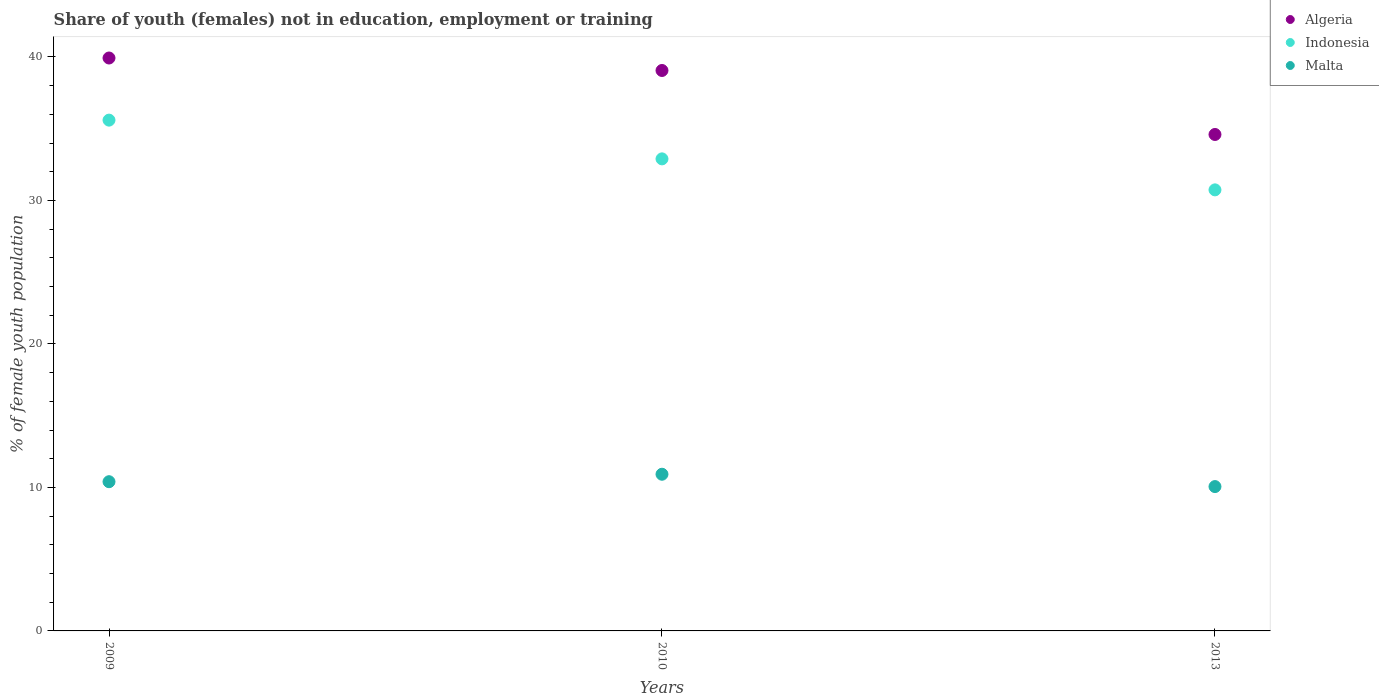How many different coloured dotlines are there?
Keep it short and to the point. 3. What is the percentage of unemployed female population in in Algeria in 2009?
Your response must be concise. 39.93. Across all years, what is the maximum percentage of unemployed female population in in Indonesia?
Offer a very short reply. 35.6. Across all years, what is the minimum percentage of unemployed female population in in Algeria?
Your answer should be compact. 34.6. In which year was the percentage of unemployed female population in in Indonesia maximum?
Provide a succinct answer. 2009. What is the total percentage of unemployed female population in in Malta in the graph?
Ensure brevity in your answer.  31.38. What is the difference between the percentage of unemployed female population in in Algeria in 2009 and that in 2010?
Your answer should be compact. 0.87. What is the difference between the percentage of unemployed female population in in Algeria in 2010 and the percentage of unemployed female population in in Malta in 2009?
Your answer should be compact. 28.66. What is the average percentage of unemployed female population in in Algeria per year?
Give a very brief answer. 37.86. In the year 2013, what is the difference between the percentage of unemployed female population in in Indonesia and percentage of unemployed female population in in Algeria?
Give a very brief answer. -3.86. In how many years, is the percentage of unemployed female population in in Algeria greater than 14 %?
Your answer should be compact. 3. What is the ratio of the percentage of unemployed female population in in Malta in 2009 to that in 2010?
Your answer should be compact. 0.95. Is the percentage of unemployed female population in in Indonesia in 2009 less than that in 2010?
Give a very brief answer. No. Is the difference between the percentage of unemployed female population in in Indonesia in 2009 and 2013 greater than the difference between the percentage of unemployed female population in in Algeria in 2009 and 2013?
Your response must be concise. No. What is the difference between the highest and the second highest percentage of unemployed female population in in Algeria?
Provide a succinct answer. 0.87. What is the difference between the highest and the lowest percentage of unemployed female population in in Algeria?
Provide a short and direct response. 5.33. What is the difference between two consecutive major ticks on the Y-axis?
Your response must be concise. 10. Does the graph contain any zero values?
Your answer should be very brief. No. Where does the legend appear in the graph?
Provide a succinct answer. Top right. How many legend labels are there?
Your answer should be compact. 3. What is the title of the graph?
Your answer should be very brief. Share of youth (females) not in education, employment or training. What is the label or title of the Y-axis?
Your answer should be very brief. % of female youth population. What is the % of female youth population of Algeria in 2009?
Your answer should be compact. 39.93. What is the % of female youth population of Indonesia in 2009?
Your answer should be very brief. 35.6. What is the % of female youth population of Malta in 2009?
Ensure brevity in your answer.  10.4. What is the % of female youth population of Algeria in 2010?
Offer a terse response. 39.06. What is the % of female youth population of Indonesia in 2010?
Make the answer very short. 32.9. What is the % of female youth population in Malta in 2010?
Provide a succinct answer. 10.92. What is the % of female youth population in Algeria in 2013?
Ensure brevity in your answer.  34.6. What is the % of female youth population of Indonesia in 2013?
Give a very brief answer. 30.74. What is the % of female youth population of Malta in 2013?
Make the answer very short. 10.06. Across all years, what is the maximum % of female youth population of Algeria?
Ensure brevity in your answer.  39.93. Across all years, what is the maximum % of female youth population of Indonesia?
Ensure brevity in your answer.  35.6. Across all years, what is the maximum % of female youth population of Malta?
Offer a very short reply. 10.92. Across all years, what is the minimum % of female youth population of Algeria?
Keep it short and to the point. 34.6. Across all years, what is the minimum % of female youth population in Indonesia?
Your answer should be very brief. 30.74. Across all years, what is the minimum % of female youth population in Malta?
Offer a terse response. 10.06. What is the total % of female youth population in Algeria in the graph?
Your response must be concise. 113.59. What is the total % of female youth population in Indonesia in the graph?
Offer a terse response. 99.24. What is the total % of female youth population of Malta in the graph?
Provide a short and direct response. 31.38. What is the difference between the % of female youth population in Algeria in 2009 and that in 2010?
Keep it short and to the point. 0.87. What is the difference between the % of female youth population in Indonesia in 2009 and that in 2010?
Keep it short and to the point. 2.7. What is the difference between the % of female youth population in Malta in 2009 and that in 2010?
Make the answer very short. -0.52. What is the difference between the % of female youth population in Algeria in 2009 and that in 2013?
Offer a terse response. 5.33. What is the difference between the % of female youth population of Indonesia in 2009 and that in 2013?
Make the answer very short. 4.86. What is the difference between the % of female youth population in Malta in 2009 and that in 2013?
Ensure brevity in your answer.  0.34. What is the difference between the % of female youth population in Algeria in 2010 and that in 2013?
Ensure brevity in your answer.  4.46. What is the difference between the % of female youth population in Indonesia in 2010 and that in 2013?
Your answer should be very brief. 2.16. What is the difference between the % of female youth population in Malta in 2010 and that in 2013?
Give a very brief answer. 0.86. What is the difference between the % of female youth population in Algeria in 2009 and the % of female youth population in Indonesia in 2010?
Provide a short and direct response. 7.03. What is the difference between the % of female youth population in Algeria in 2009 and the % of female youth population in Malta in 2010?
Provide a short and direct response. 29.01. What is the difference between the % of female youth population of Indonesia in 2009 and the % of female youth population of Malta in 2010?
Offer a very short reply. 24.68. What is the difference between the % of female youth population of Algeria in 2009 and the % of female youth population of Indonesia in 2013?
Ensure brevity in your answer.  9.19. What is the difference between the % of female youth population in Algeria in 2009 and the % of female youth population in Malta in 2013?
Offer a very short reply. 29.87. What is the difference between the % of female youth population of Indonesia in 2009 and the % of female youth population of Malta in 2013?
Your answer should be compact. 25.54. What is the difference between the % of female youth population of Algeria in 2010 and the % of female youth population of Indonesia in 2013?
Your answer should be very brief. 8.32. What is the difference between the % of female youth population in Algeria in 2010 and the % of female youth population in Malta in 2013?
Make the answer very short. 29. What is the difference between the % of female youth population of Indonesia in 2010 and the % of female youth population of Malta in 2013?
Offer a very short reply. 22.84. What is the average % of female youth population in Algeria per year?
Give a very brief answer. 37.86. What is the average % of female youth population in Indonesia per year?
Keep it short and to the point. 33.08. What is the average % of female youth population in Malta per year?
Offer a terse response. 10.46. In the year 2009, what is the difference between the % of female youth population of Algeria and % of female youth population of Indonesia?
Your answer should be compact. 4.33. In the year 2009, what is the difference between the % of female youth population of Algeria and % of female youth population of Malta?
Your response must be concise. 29.53. In the year 2009, what is the difference between the % of female youth population of Indonesia and % of female youth population of Malta?
Make the answer very short. 25.2. In the year 2010, what is the difference between the % of female youth population in Algeria and % of female youth population in Indonesia?
Ensure brevity in your answer.  6.16. In the year 2010, what is the difference between the % of female youth population in Algeria and % of female youth population in Malta?
Provide a short and direct response. 28.14. In the year 2010, what is the difference between the % of female youth population of Indonesia and % of female youth population of Malta?
Offer a terse response. 21.98. In the year 2013, what is the difference between the % of female youth population in Algeria and % of female youth population in Indonesia?
Your response must be concise. 3.86. In the year 2013, what is the difference between the % of female youth population in Algeria and % of female youth population in Malta?
Offer a terse response. 24.54. In the year 2013, what is the difference between the % of female youth population of Indonesia and % of female youth population of Malta?
Your response must be concise. 20.68. What is the ratio of the % of female youth population of Algeria in 2009 to that in 2010?
Your answer should be compact. 1.02. What is the ratio of the % of female youth population of Indonesia in 2009 to that in 2010?
Your answer should be very brief. 1.08. What is the ratio of the % of female youth population in Malta in 2009 to that in 2010?
Provide a short and direct response. 0.95. What is the ratio of the % of female youth population in Algeria in 2009 to that in 2013?
Ensure brevity in your answer.  1.15. What is the ratio of the % of female youth population of Indonesia in 2009 to that in 2013?
Offer a terse response. 1.16. What is the ratio of the % of female youth population in Malta in 2009 to that in 2013?
Keep it short and to the point. 1.03. What is the ratio of the % of female youth population of Algeria in 2010 to that in 2013?
Give a very brief answer. 1.13. What is the ratio of the % of female youth population of Indonesia in 2010 to that in 2013?
Keep it short and to the point. 1.07. What is the ratio of the % of female youth population in Malta in 2010 to that in 2013?
Provide a short and direct response. 1.09. What is the difference between the highest and the second highest % of female youth population of Algeria?
Your answer should be compact. 0.87. What is the difference between the highest and the second highest % of female youth population in Malta?
Offer a very short reply. 0.52. What is the difference between the highest and the lowest % of female youth population of Algeria?
Make the answer very short. 5.33. What is the difference between the highest and the lowest % of female youth population in Indonesia?
Your answer should be compact. 4.86. What is the difference between the highest and the lowest % of female youth population of Malta?
Offer a terse response. 0.86. 